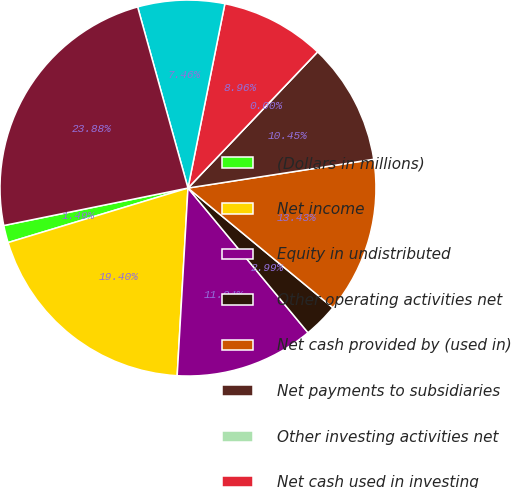<chart> <loc_0><loc_0><loc_500><loc_500><pie_chart><fcel>(Dollars in millions)<fcel>Net income<fcel>Equity in undistributed<fcel>Other operating activities net<fcel>Net cash provided by (used in)<fcel>Net payments to subsidiaries<fcel>Other investing activities net<fcel>Net cash used in investing<fcel>Net increase (decrease) in<fcel>Proceeds from issuance of<nl><fcel>1.49%<fcel>19.4%<fcel>11.94%<fcel>2.99%<fcel>13.43%<fcel>10.45%<fcel>0.0%<fcel>8.96%<fcel>7.46%<fcel>23.88%<nl></chart> 